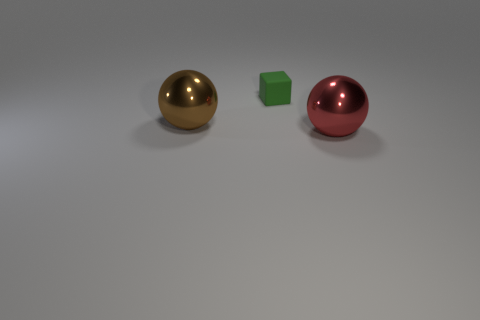What materials do the objects in the image appear to be made from? The objects seem to be rendered with different materials. The sphere on the left has a reflective surface that suggests it's made of a polished metal, possibly gold. The central object, a cube, appears to have a matte finish that might be indicative of plastic or painted wood. The sphere on the right also has a reflective quality, similar to the first, implying a metallic material, perhaps painted red. 